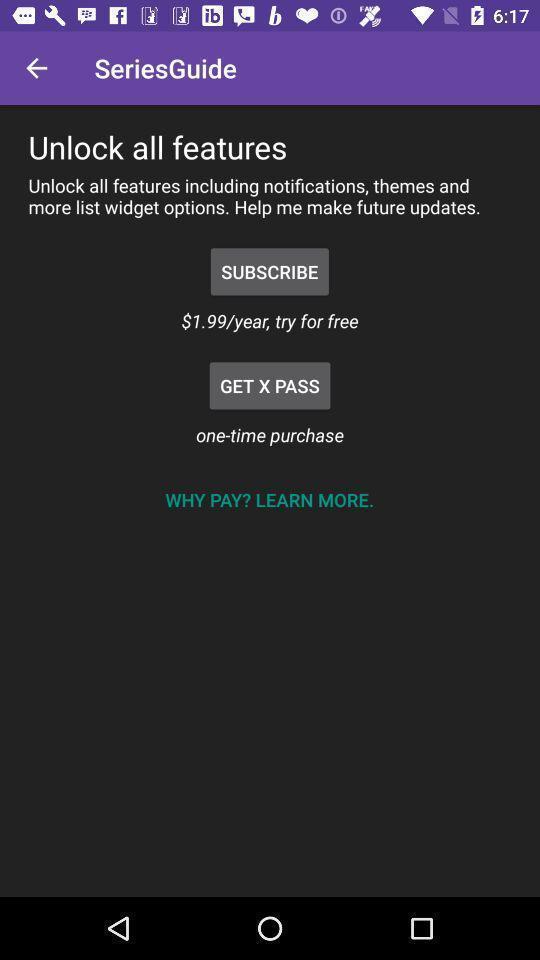Give me a narrative description of this picture. Subscription page for purchasing. 